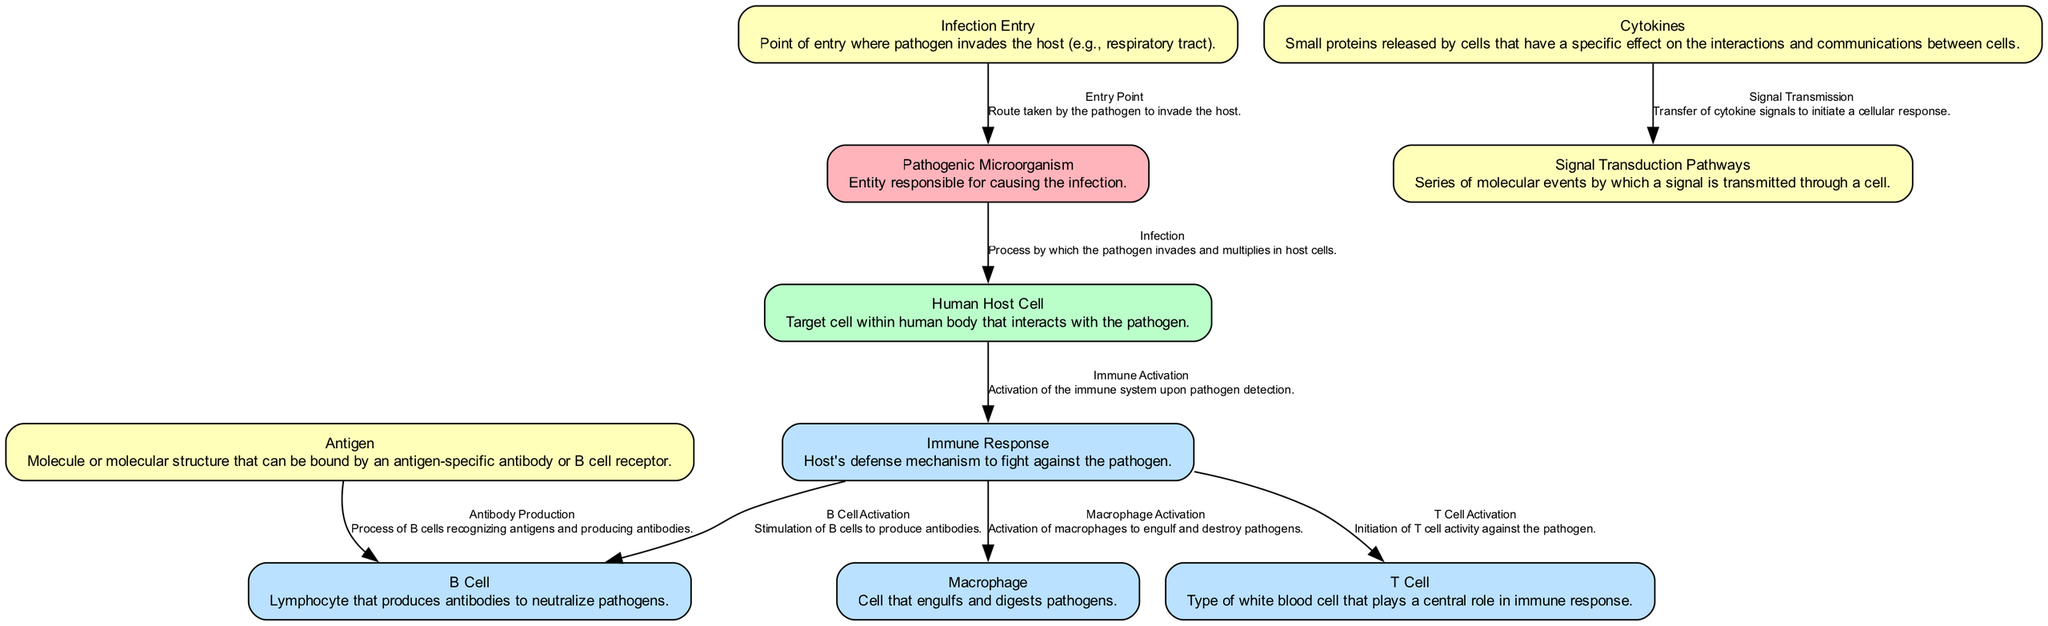What is the label of the node that represents the entity responsible for causing the infection? The node labeled "Pathogenic Microorganism" is identified as the entity responsible for causing the infection.
Answer: Pathogenic Microorganism How many nodes are present in the diagram? The diagram contains a total of ten nodes related to the interactions between the pathogen and the human host.
Answer: 10 What is the label of the edge that describes the activation of T cells? The edge that describes the activation of T cells is labeled "T Cell Activation". It connects the immune response to the T cell node.
Answer: T Cell Activation Which cell type is responsible for engulfing and digesting pathogens? The "Macrophage" node is responsible for engulfing and digesting pathogens, as indicated in the description of the diagram.
Answer: Macrophage What flow occurs after the host cell detects the pathogen? Upon detection of the pathogen, the host cell activates the immune response, which subsequently activates macrophages, T cells, and B cells.
Answer: Immune Activation What is the role of cytokines in the signal transduction process? Cytokines transmit signals that initiate a cellular response by impacting signal transduction pathways. This is indicated in the relationship outlined in the diagram.
Answer: Signal Transmission How many types of immune cells are mentioned in the diagram? The diagram mentions three specific types of immune cells: macrophages, T cells, and B cells.
Answer: 3 What is the relationship between antigens and B cells? The relationship is defined as "Antibody Production", where antigens are recognized by B cells that then produce antibodies.
Answer: Antibody Production Which node indicates the point where the pathogen enters the host? The node labeled "Infection Entry" indicates the specific point where the pathogen invades the host.
Answer: Infection Entry What do cytokines affect in the diagram? Cytokines affect the signal transduction pathways by facilitating the transfer of signals needed to initiate further cellular responses.
Answer: Signal Transduction Pathways 